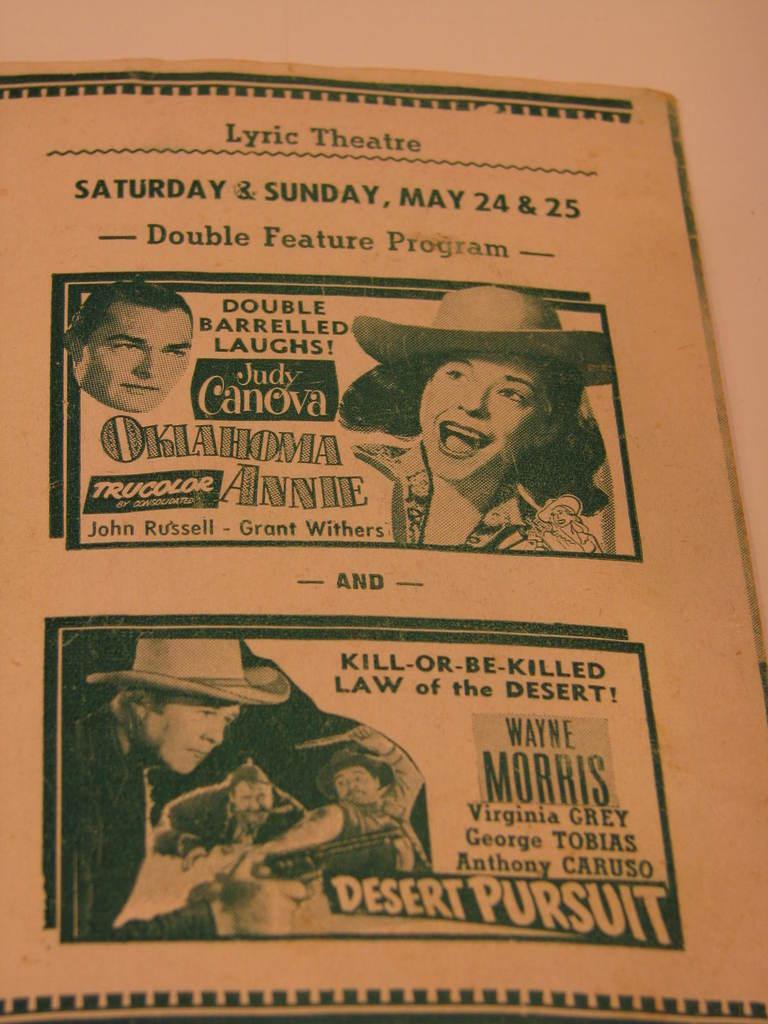What is present in the image that contains visual information? There is a poster in the image. What type of images can be seen on the poster? The poster contains pictures of persons. Is there any text on the poster? Yes, there is text written on the poster. What color is the cherry on the wrist of the person in the image? There is no cherry or wrist visible in the image; the poster contains pictures of persons but does not show any specific details about their wrists or accessories. 